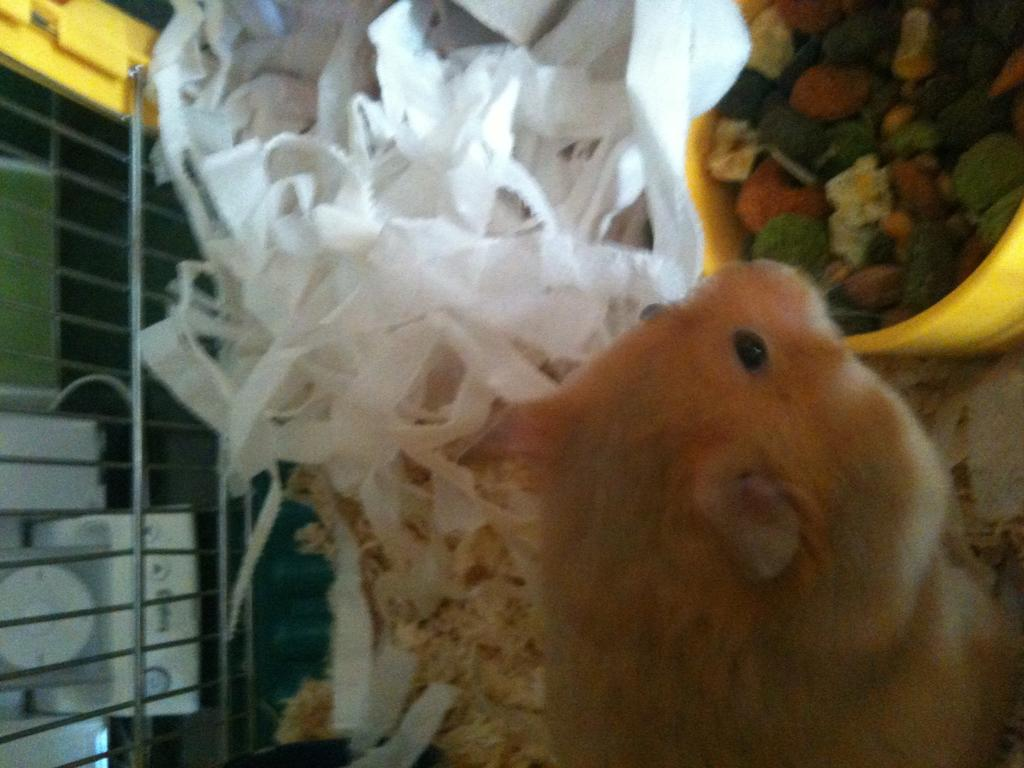What type of animal is in the image? The type of animal cannot be determined from the provided facts. What are the cloth pieces used for in the image? The purpose of the cloth pieces cannot be determined from the provided facts. What are the rods used for in the image? The purpose of the rods cannot be determined from the provided facts. What is in the bowl in the image? The contents of the bowl cannot be determined from the provided facts. Can you describe the unspecified objects in the image? The nature of the unspecified objects cannot be determined from the provided facts. What channel is the doctor watching in the shade in the image? There is no mention of a channel, doctor, or shade in the provided facts, so this question cannot be answered. 